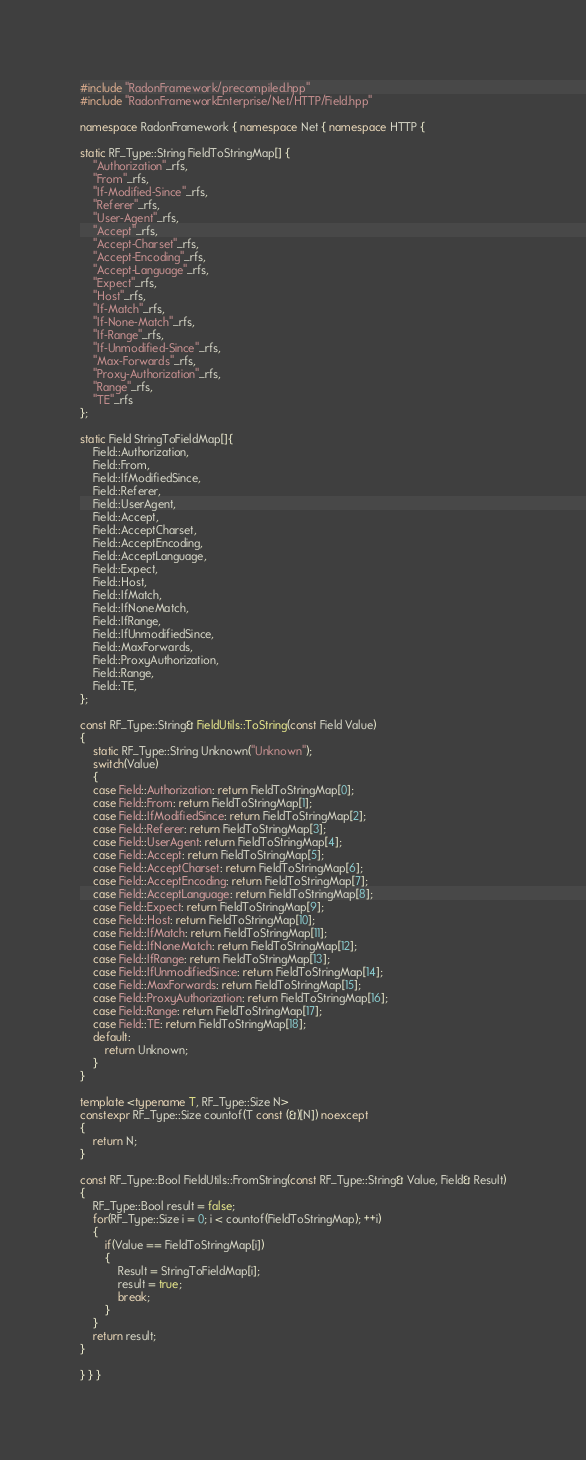Convert code to text. <code><loc_0><loc_0><loc_500><loc_500><_C++_>#include "RadonFramework/precompiled.hpp"
#include "RadonFrameworkEnterprise/Net/HTTP/Field.hpp"

namespace RadonFramework { namespace Net { namespace HTTP {

static RF_Type::String FieldToStringMap[] {
    "Authorization"_rfs,
    "From"_rfs,
    "If-Modified-Since"_rfs,
    "Referer"_rfs,
    "User-Agent"_rfs,
    "Accept"_rfs,
    "Accept-Charset"_rfs,
    "Accept-Encoding"_rfs,
    "Accept-Language"_rfs,
    "Expect"_rfs,
    "Host"_rfs,
    "If-Match"_rfs,
    "If-None-Match"_rfs,
    "If-Range"_rfs,
    "If-Unmodified-Since"_rfs,
    "Max-Forwards"_rfs,
    "Proxy-Authorization"_rfs,
    "Range"_rfs,
    "TE"_rfs
};

static Field StringToFieldMap[]{
    Field::Authorization,
    Field::From,
    Field::IfModifiedSince,
    Field::Referer,
    Field::UserAgent,
    Field::Accept,
    Field::AcceptCharset,
    Field::AcceptEncoding,
    Field::AcceptLanguage,
    Field::Expect,
    Field::Host,
    Field::IfMatch,
    Field::IfNoneMatch,
    Field::IfRange,
    Field::IfUnmodifiedSince,
    Field::MaxForwards,
    Field::ProxyAuthorization,
    Field::Range,
    Field::TE,
};

const RF_Type::String& FieldUtils::ToString(const Field Value)
{
    static RF_Type::String Unknown("Unknown");
    switch(Value)
    {
    case Field::Authorization: return FieldToStringMap[0];
    case Field::From: return FieldToStringMap[1];
    case Field::IfModifiedSince: return FieldToStringMap[2];
    case Field::Referer: return FieldToStringMap[3];
    case Field::UserAgent: return FieldToStringMap[4];
    case Field::Accept: return FieldToStringMap[5];
    case Field::AcceptCharset: return FieldToStringMap[6];
    case Field::AcceptEncoding: return FieldToStringMap[7];
    case Field::AcceptLanguage: return FieldToStringMap[8];
    case Field::Expect: return FieldToStringMap[9];
    case Field::Host: return FieldToStringMap[10];
    case Field::IfMatch: return FieldToStringMap[11];
    case Field::IfNoneMatch: return FieldToStringMap[12];
    case Field::IfRange: return FieldToStringMap[13];
    case Field::IfUnmodifiedSince: return FieldToStringMap[14];
    case Field::MaxForwards: return FieldToStringMap[15];
    case Field::ProxyAuthorization: return FieldToStringMap[16];
    case Field::Range: return FieldToStringMap[17];
    case Field::TE: return FieldToStringMap[18];
    default:
        return Unknown;
    }
}

template <typename T, RF_Type::Size N>
constexpr RF_Type::Size countof(T const (&)[N]) noexcept
{
    return N;
}

const RF_Type::Bool FieldUtils::FromString(const RF_Type::String& Value, Field& Result)
{
    RF_Type::Bool result = false;
    for(RF_Type::Size i = 0; i < countof(FieldToStringMap); ++i)
    {
        if(Value == FieldToStringMap[i])
        {
            Result = StringToFieldMap[i];
            result = true;
            break;
        }
    }
    return result;
}

} } }</code> 